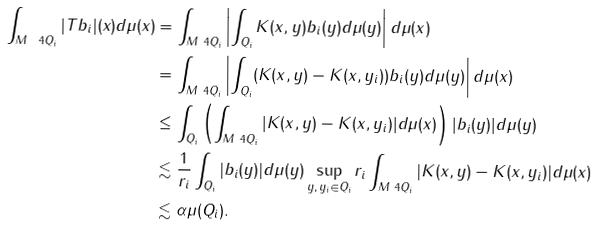<formula> <loc_0><loc_0><loc_500><loc_500>\int _ { M \ 4 Q _ { i } } | T b _ { i } | ( x ) d \mu ( x ) & = \int _ { M \ 4 Q _ { i } } \left | \int _ { Q _ { i } } K ( x , y ) b _ { i } ( y ) d \mu ( y ) \right | d \mu ( x ) \\ & = \int _ { M \ 4 Q _ { i } } \left | \int _ { Q _ { i } } ( K ( x , y ) - K ( x , y _ { i } ) ) b _ { i } ( y ) d \mu ( y ) \right | d \mu ( x ) \\ & \leq \int _ { Q _ { i } } \left ( \int _ { M \ 4 Q _ { i } } | K ( x , y ) - K ( x , y _ { i } ) | d \mu ( x ) \right ) | b _ { i } ( y ) | d \mu ( y ) \\ & \lesssim \frac { 1 } { r _ { i } } \int _ { Q _ { i } } | b _ { i } ( y ) | d \mu ( y ) \sup _ { y , \, y _ { i } \in Q _ { i } } r _ { i } \int _ { M \ 4 Q _ { i } } | K ( x , y ) - K ( x , y _ { i } ) | d \mu ( x ) \\ & \lesssim \alpha \mu ( Q _ { i } ) .</formula> 